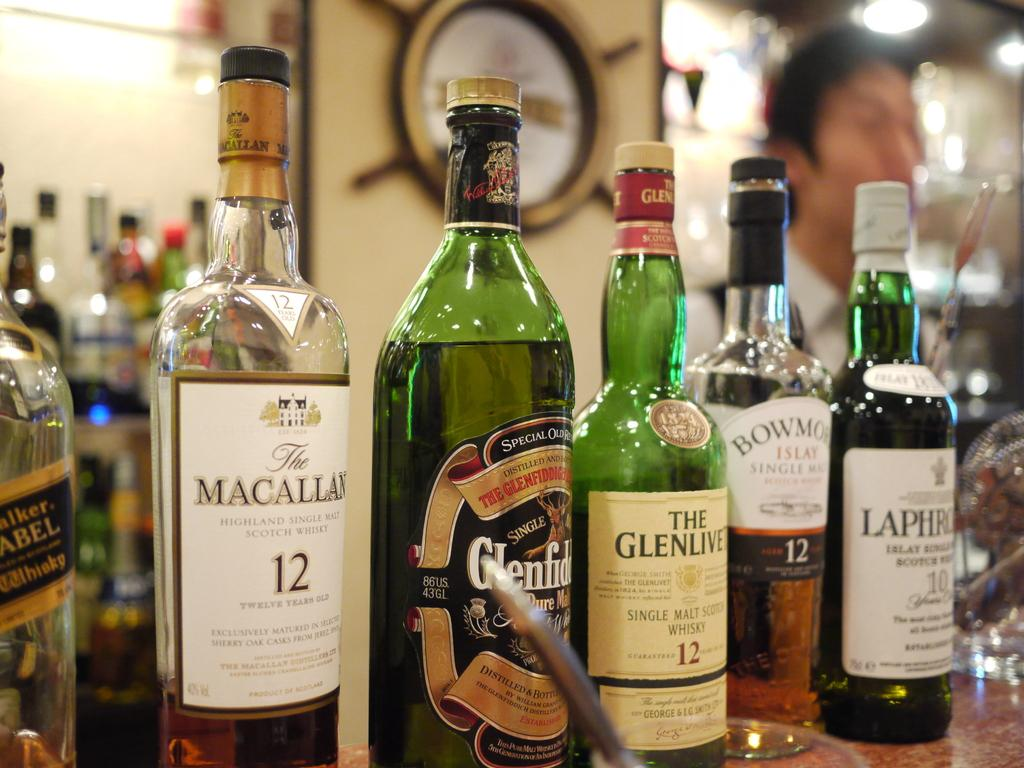<image>
Create a compact narrative representing the image presented. A bottle of Macallan 12 sits on the wooden table 